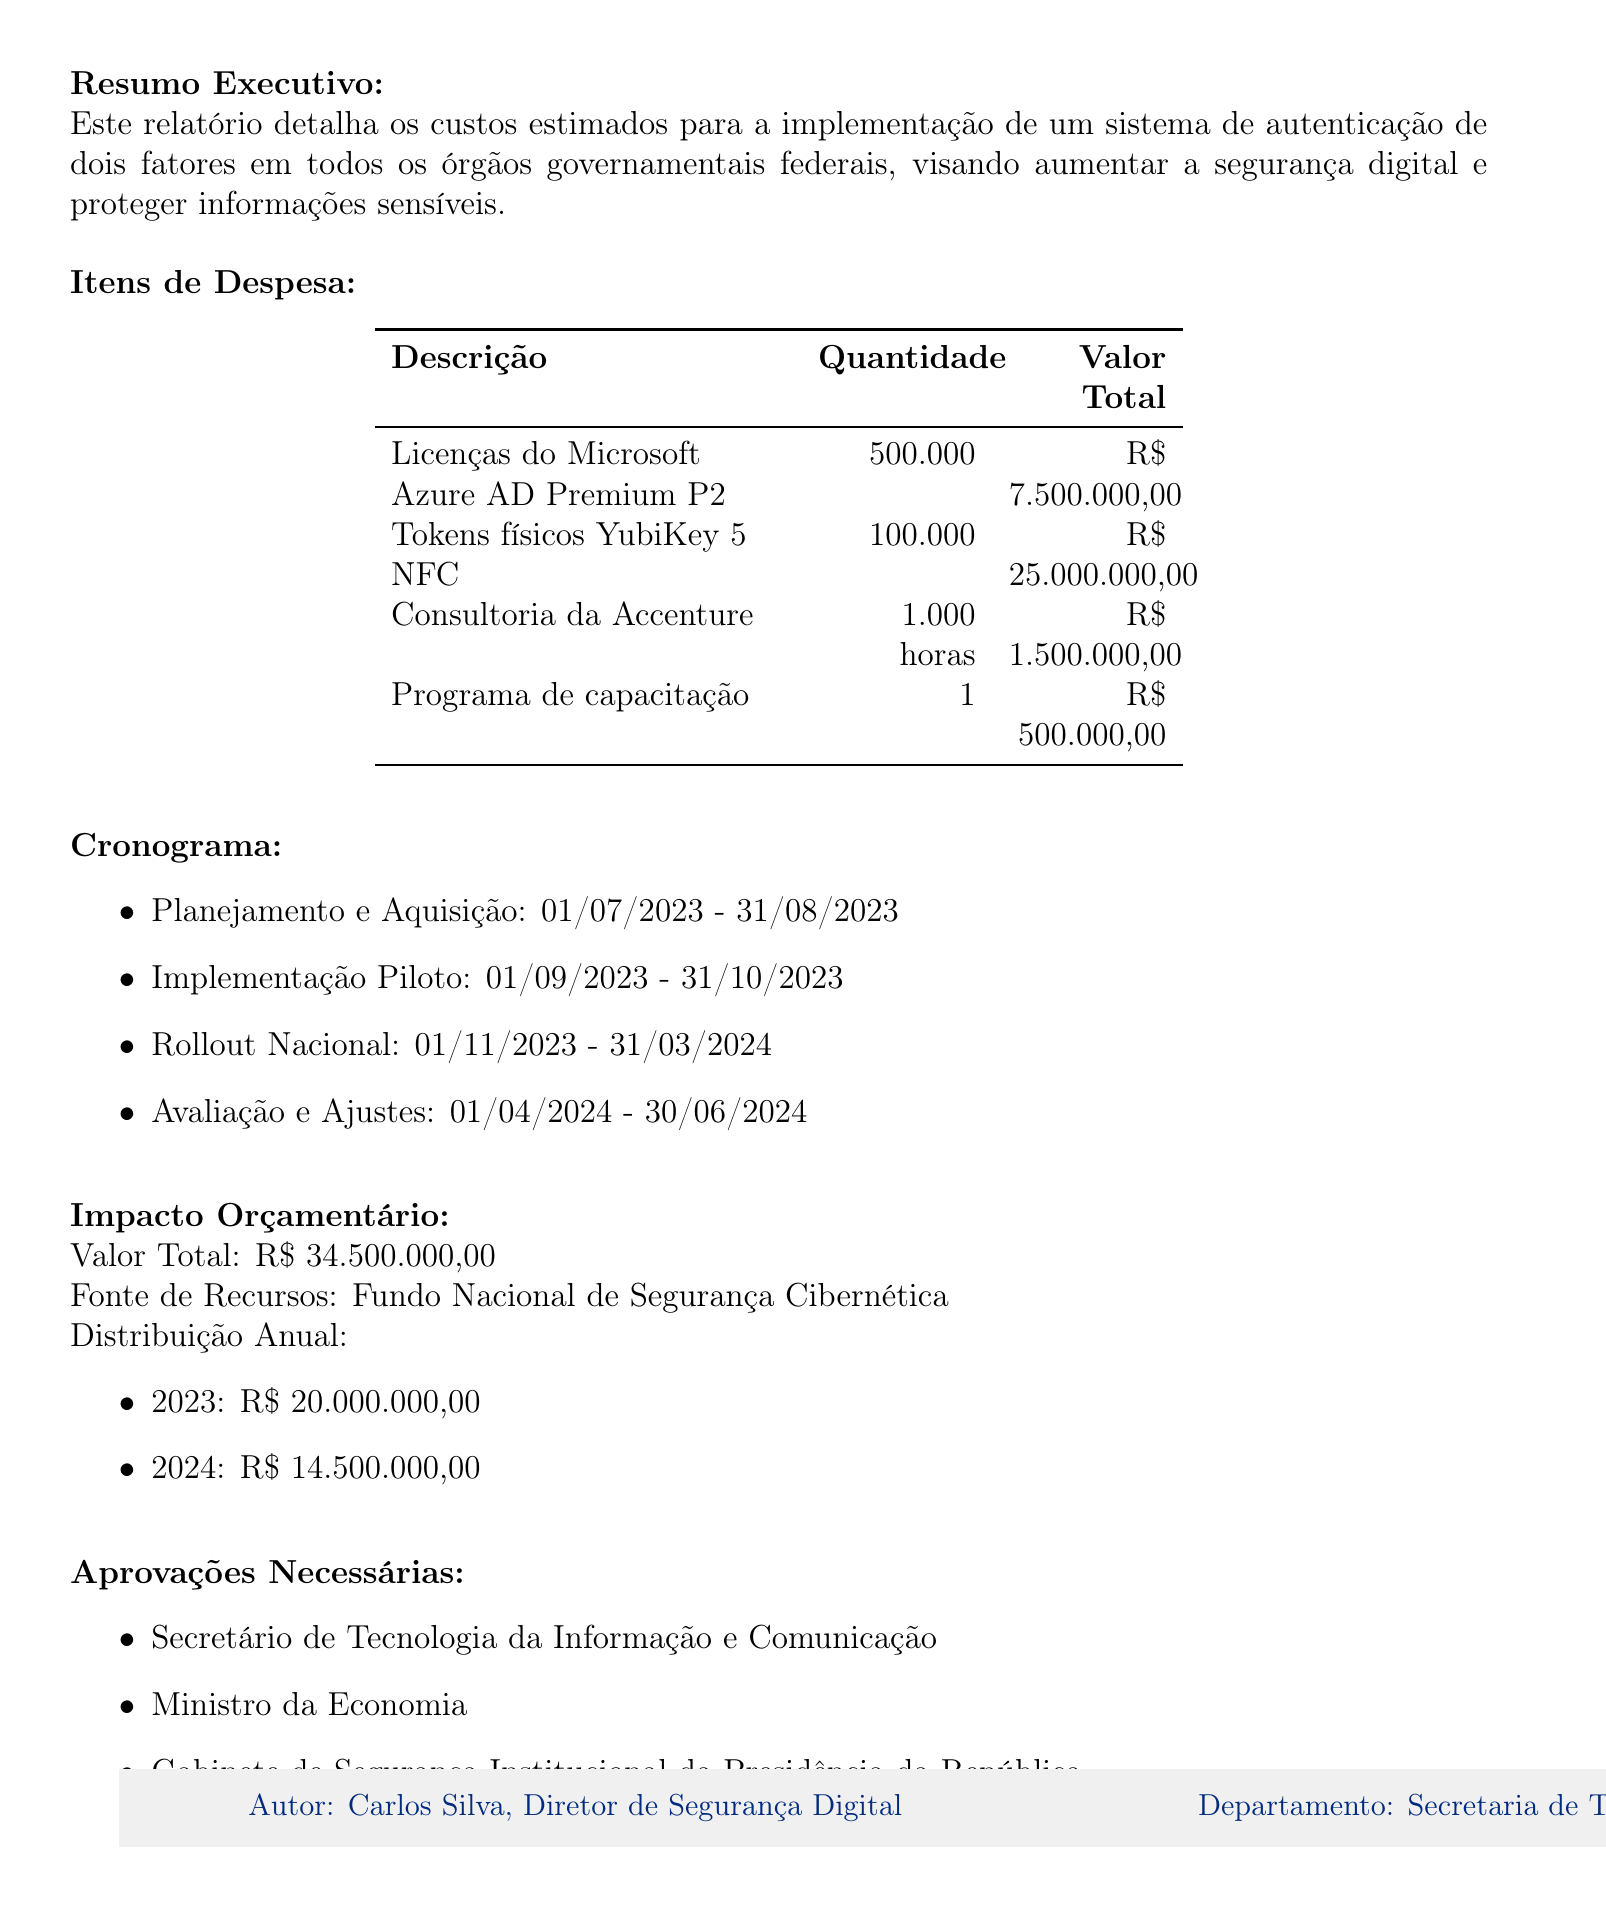qual é a data do relatório? A data do relatório está claramente indicada na parte superior do documento.
Answer: 15 de maio de 2023 quem é o autor do relatório? O autor do relatório é mencionado no rodapé do documento.
Answer: Carlos Silva, Diretor de Segurança Digital qual é o valor total estimado para a implementação do sistema? O valor total é detalhado na seção de impacto orçamentário do documento.
Answer: 34.500.000,00 quais são as aprovações necessárias? As aprovações necessárias são listadas em uma seção específica do documento.
Answer: Secretário de Tecnologia da Informação e Comunicação, Ministro da Economia, Gabinete de Segurança Institucional da Presidência da República qual é a categoria e descrição do item de maior despesa? O item com maior despesa pode ser encontrado na tabela de itens de despesa, que lista as categorias e descrições.
Answer: Hardware, Tokens físicos YubiKey 5 NFC quantos itens de despesa estão listados no relatório? O número de itens de despesa pode ser contado na tabela correspondente do documento.
Answer: 4 qual é a fase do cronograma que começa em novembro de 2023? A fase correspondente é mencionada em um item específico na seção do cronograma.
Answer: Rollout Nacional por que a implementação do sistema é considerada crucial? A justificativa fornecida no documento explica a importância da implementação do sistema.
Answer: Fortalecer a segurança digital do governo federal qual é a fonte de recursos mencionada no impacto orçamentário? A fonte de recursos é especificada claramente na seção de impacto orçamentário.
Answer: Fundo Nacional de Segurança Cibernética 